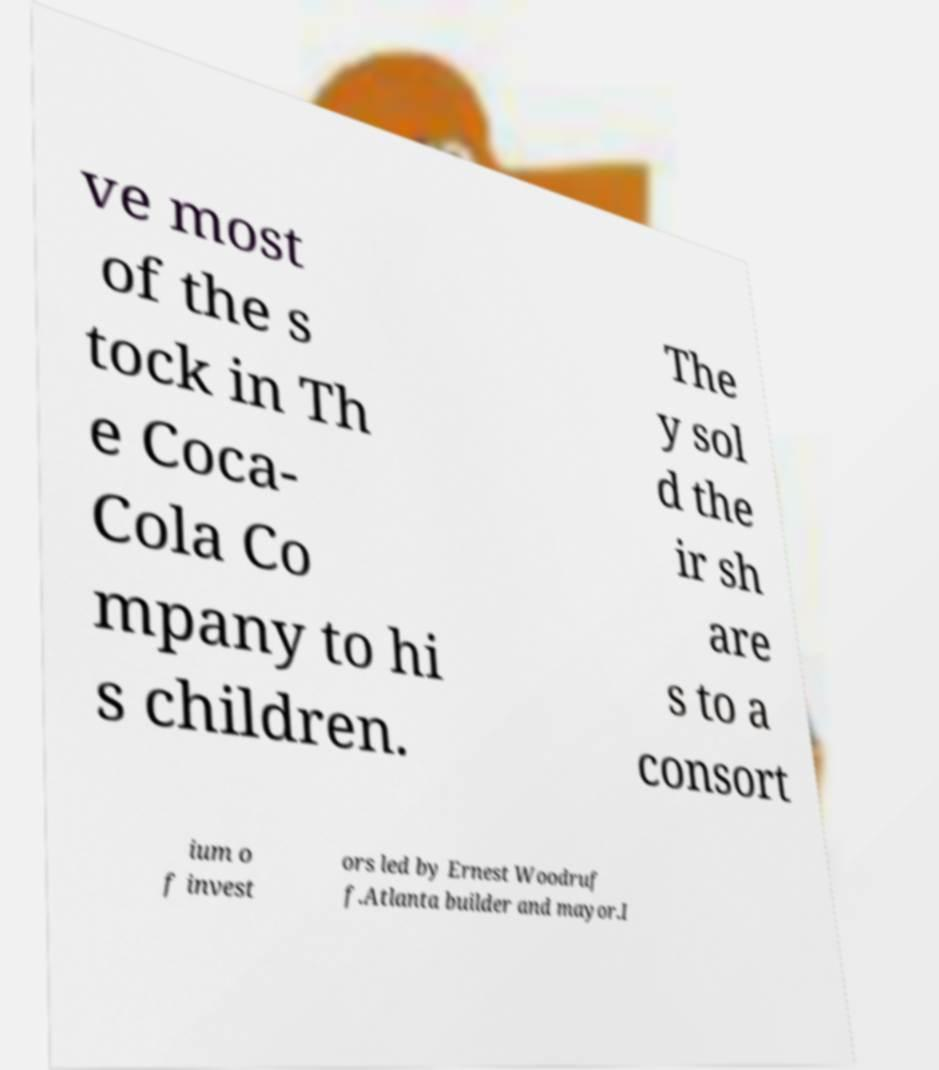For documentation purposes, I need the text within this image transcribed. Could you provide that? ve most of the s tock in Th e Coca- Cola Co mpany to hi s children. The y sol d the ir sh are s to a consort ium o f invest ors led by Ernest Woodruf f.Atlanta builder and mayor.I 